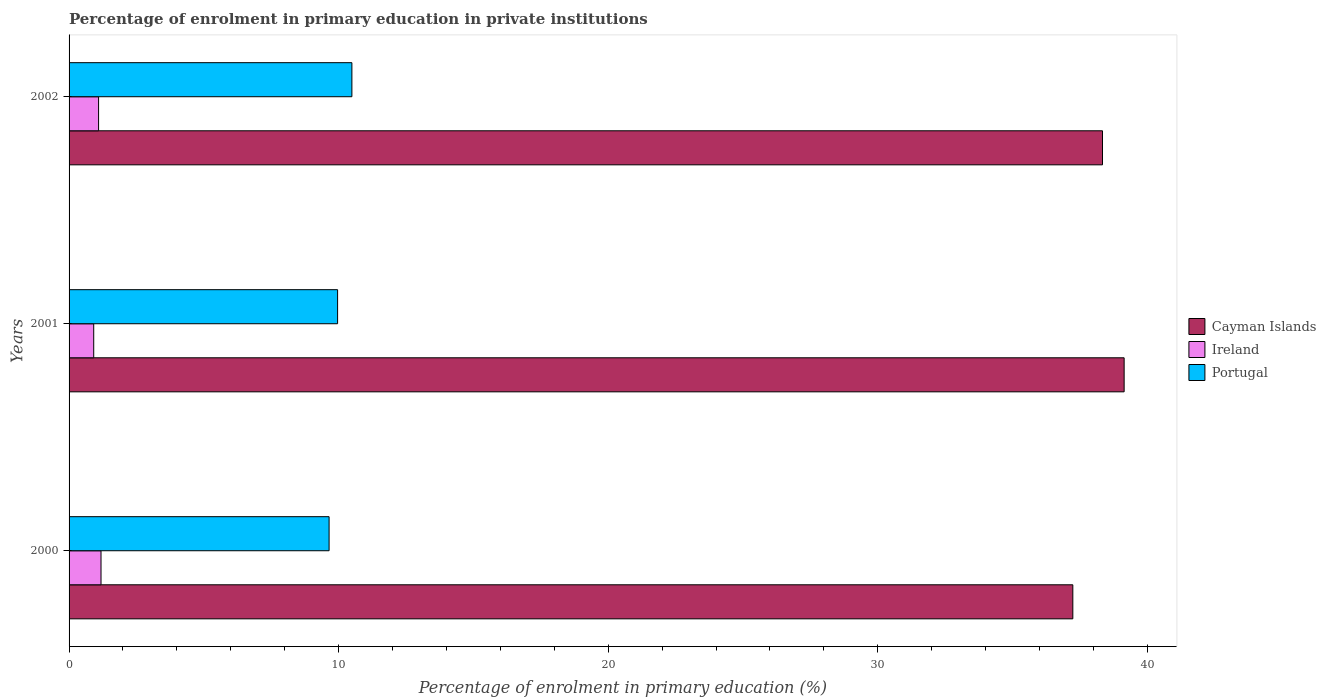How many different coloured bars are there?
Offer a very short reply. 3. Are the number of bars on each tick of the Y-axis equal?
Your response must be concise. Yes. How many bars are there on the 2nd tick from the top?
Offer a very short reply. 3. How many bars are there on the 1st tick from the bottom?
Your answer should be compact. 3. What is the label of the 3rd group of bars from the top?
Make the answer very short. 2000. What is the percentage of enrolment in primary education in Portugal in 2000?
Your answer should be very brief. 9.65. Across all years, what is the maximum percentage of enrolment in primary education in Ireland?
Ensure brevity in your answer.  1.18. Across all years, what is the minimum percentage of enrolment in primary education in Ireland?
Your response must be concise. 0.91. In which year was the percentage of enrolment in primary education in Cayman Islands maximum?
Make the answer very short. 2001. What is the total percentage of enrolment in primary education in Cayman Islands in the graph?
Your response must be concise. 114.71. What is the difference between the percentage of enrolment in primary education in Portugal in 2000 and that in 2001?
Your answer should be very brief. -0.32. What is the difference between the percentage of enrolment in primary education in Ireland in 2001 and the percentage of enrolment in primary education in Portugal in 2002?
Keep it short and to the point. -9.58. What is the average percentage of enrolment in primary education in Cayman Islands per year?
Give a very brief answer. 38.24. In the year 2000, what is the difference between the percentage of enrolment in primary education in Portugal and percentage of enrolment in primary education in Cayman Islands?
Give a very brief answer. -27.59. What is the ratio of the percentage of enrolment in primary education in Ireland in 2000 to that in 2001?
Provide a succinct answer. 1.3. Is the percentage of enrolment in primary education in Ireland in 2000 less than that in 2002?
Provide a short and direct response. No. Is the difference between the percentage of enrolment in primary education in Portugal in 2000 and 2002 greater than the difference between the percentage of enrolment in primary education in Cayman Islands in 2000 and 2002?
Your answer should be compact. Yes. What is the difference between the highest and the second highest percentage of enrolment in primary education in Ireland?
Provide a short and direct response. 0.09. What is the difference between the highest and the lowest percentage of enrolment in primary education in Cayman Islands?
Keep it short and to the point. 1.9. In how many years, is the percentage of enrolment in primary education in Cayman Islands greater than the average percentage of enrolment in primary education in Cayman Islands taken over all years?
Your answer should be very brief. 2. Is the sum of the percentage of enrolment in primary education in Ireland in 2000 and 2002 greater than the maximum percentage of enrolment in primary education in Cayman Islands across all years?
Ensure brevity in your answer.  No. What does the 2nd bar from the top in 2000 represents?
Ensure brevity in your answer.  Ireland. What does the 2nd bar from the bottom in 2000 represents?
Your answer should be compact. Ireland. Is it the case that in every year, the sum of the percentage of enrolment in primary education in Ireland and percentage of enrolment in primary education in Portugal is greater than the percentage of enrolment in primary education in Cayman Islands?
Ensure brevity in your answer.  No. How many years are there in the graph?
Keep it short and to the point. 3. What is the difference between two consecutive major ticks on the X-axis?
Provide a short and direct response. 10. Are the values on the major ticks of X-axis written in scientific E-notation?
Provide a short and direct response. No. Does the graph contain any zero values?
Your response must be concise. No. Does the graph contain grids?
Your response must be concise. No. What is the title of the graph?
Make the answer very short. Percentage of enrolment in primary education in private institutions. Does "Congo (Republic)" appear as one of the legend labels in the graph?
Provide a short and direct response. No. What is the label or title of the X-axis?
Your response must be concise. Percentage of enrolment in primary education (%). What is the Percentage of enrolment in primary education (%) in Cayman Islands in 2000?
Provide a short and direct response. 37.23. What is the Percentage of enrolment in primary education (%) in Ireland in 2000?
Make the answer very short. 1.18. What is the Percentage of enrolment in primary education (%) in Portugal in 2000?
Your answer should be compact. 9.65. What is the Percentage of enrolment in primary education (%) in Cayman Islands in 2001?
Offer a terse response. 39.14. What is the Percentage of enrolment in primary education (%) of Ireland in 2001?
Offer a terse response. 0.91. What is the Percentage of enrolment in primary education (%) of Portugal in 2001?
Offer a terse response. 9.96. What is the Percentage of enrolment in primary education (%) in Cayman Islands in 2002?
Your response must be concise. 38.33. What is the Percentage of enrolment in primary education (%) in Ireland in 2002?
Your response must be concise. 1.09. What is the Percentage of enrolment in primary education (%) in Portugal in 2002?
Make the answer very short. 10.49. Across all years, what is the maximum Percentage of enrolment in primary education (%) of Cayman Islands?
Ensure brevity in your answer.  39.14. Across all years, what is the maximum Percentage of enrolment in primary education (%) of Ireland?
Your answer should be compact. 1.18. Across all years, what is the maximum Percentage of enrolment in primary education (%) of Portugal?
Your answer should be very brief. 10.49. Across all years, what is the minimum Percentage of enrolment in primary education (%) in Cayman Islands?
Provide a succinct answer. 37.23. Across all years, what is the minimum Percentage of enrolment in primary education (%) in Ireland?
Provide a short and direct response. 0.91. Across all years, what is the minimum Percentage of enrolment in primary education (%) of Portugal?
Offer a terse response. 9.65. What is the total Percentage of enrolment in primary education (%) in Cayman Islands in the graph?
Offer a terse response. 114.71. What is the total Percentage of enrolment in primary education (%) of Ireland in the graph?
Make the answer very short. 3.19. What is the total Percentage of enrolment in primary education (%) in Portugal in the graph?
Ensure brevity in your answer.  30.1. What is the difference between the Percentage of enrolment in primary education (%) of Cayman Islands in 2000 and that in 2001?
Your answer should be compact. -1.9. What is the difference between the Percentage of enrolment in primary education (%) of Ireland in 2000 and that in 2001?
Keep it short and to the point. 0.27. What is the difference between the Percentage of enrolment in primary education (%) in Portugal in 2000 and that in 2001?
Ensure brevity in your answer.  -0.32. What is the difference between the Percentage of enrolment in primary education (%) of Cayman Islands in 2000 and that in 2002?
Provide a short and direct response. -1.1. What is the difference between the Percentage of enrolment in primary education (%) in Ireland in 2000 and that in 2002?
Ensure brevity in your answer.  0.09. What is the difference between the Percentage of enrolment in primary education (%) of Portugal in 2000 and that in 2002?
Your answer should be compact. -0.85. What is the difference between the Percentage of enrolment in primary education (%) in Cayman Islands in 2001 and that in 2002?
Provide a short and direct response. 0.8. What is the difference between the Percentage of enrolment in primary education (%) of Ireland in 2001 and that in 2002?
Provide a succinct answer. -0.18. What is the difference between the Percentage of enrolment in primary education (%) in Portugal in 2001 and that in 2002?
Keep it short and to the point. -0.53. What is the difference between the Percentage of enrolment in primary education (%) in Cayman Islands in 2000 and the Percentage of enrolment in primary education (%) in Ireland in 2001?
Give a very brief answer. 36.32. What is the difference between the Percentage of enrolment in primary education (%) in Cayman Islands in 2000 and the Percentage of enrolment in primary education (%) in Portugal in 2001?
Make the answer very short. 27.27. What is the difference between the Percentage of enrolment in primary education (%) in Ireland in 2000 and the Percentage of enrolment in primary education (%) in Portugal in 2001?
Provide a succinct answer. -8.78. What is the difference between the Percentage of enrolment in primary education (%) in Cayman Islands in 2000 and the Percentage of enrolment in primary education (%) in Ireland in 2002?
Provide a succinct answer. 36.14. What is the difference between the Percentage of enrolment in primary education (%) of Cayman Islands in 2000 and the Percentage of enrolment in primary education (%) of Portugal in 2002?
Provide a short and direct response. 26.74. What is the difference between the Percentage of enrolment in primary education (%) in Ireland in 2000 and the Percentage of enrolment in primary education (%) in Portugal in 2002?
Provide a succinct answer. -9.31. What is the difference between the Percentage of enrolment in primary education (%) in Cayman Islands in 2001 and the Percentage of enrolment in primary education (%) in Ireland in 2002?
Make the answer very short. 38.04. What is the difference between the Percentage of enrolment in primary education (%) of Cayman Islands in 2001 and the Percentage of enrolment in primary education (%) of Portugal in 2002?
Make the answer very short. 28.65. What is the difference between the Percentage of enrolment in primary education (%) in Ireland in 2001 and the Percentage of enrolment in primary education (%) in Portugal in 2002?
Offer a very short reply. -9.58. What is the average Percentage of enrolment in primary education (%) in Cayman Islands per year?
Ensure brevity in your answer.  38.24. What is the average Percentage of enrolment in primary education (%) in Ireland per year?
Your answer should be very brief. 1.06. What is the average Percentage of enrolment in primary education (%) of Portugal per year?
Offer a terse response. 10.03. In the year 2000, what is the difference between the Percentage of enrolment in primary education (%) of Cayman Islands and Percentage of enrolment in primary education (%) of Ireland?
Your answer should be very brief. 36.05. In the year 2000, what is the difference between the Percentage of enrolment in primary education (%) in Cayman Islands and Percentage of enrolment in primary education (%) in Portugal?
Make the answer very short. 27.59. In the year 2000, what is the difference between the Percentage of enrolment in primary education (%) in Ireland and Percentage of enrolment in primary education (%) in Portugal?
Provide a succinct answer. -8.46. In the year 2001, what is the difference between the Percentage of enrolment in primary education (%) in Cayman Islands and Percentage of enrolment in primary education (%) in Ireland?
Give a very brief answer. 38.22. In the year 2001, what is the difference between the Percentage of enrolment in primary education (%) of Cayman Islands and Percentage of enrolment in primary education (%) of Portugal?
Provide a short and direct response. 29.18. In the year 2001, what is the difference between the Percentage of enrolment in primary education (%) of Ireland and Percentage of enrolment in primary education (%) of Portugal?
Make the answer very short. -9.05. In the year 2002, what is the difference between the Percentage of enrolment in primary education (%) in Cayman Islands and Percentage of enrolment in primary education (%) in Ireland?
Give a very brief answer. 37.24. In the year 2002, what is the difference between the Percentage of enrolment in primary education (%) in Cayman Islands and Percentage of enrolment in primary education (%) in Portugal?
Make the answer very short. 27.84. In the year 2002, what is the difference between the Percentage of enrolment in primary education (%) of Ireland and Percentage of enrolment in primary education (%) of Portugal?
Your response must be concise. -9.4. What is the ratio of the Percentage of enrolment in primary education (%) of Cayman Islands in 2000 to that in 2001?
Give a very brief answer. 0.95. What is the ratio of the Percentage of enrolment in primary education (%) of Ireland in 2000 to that in 2001?
Keep it short and to the point. 1.3. What is the ratio of the Percentage of enrolment in primary education (%) in Portugal in 2000 to that in 2001?
Offer a very short reply. 0.97. What is the ratio of the Percentage of enrolment in primary education (%) in Cayman Islands in 2000 to that in 2002?
Give a very brief answer. 0.97. What is the ratio of the Percentage of enrolment in primary education (%) in Ireland in 2000 to that in 2002?
Make the answer very short. 1.08. What is the ratio of the Percentage of enrolment in primary education (%) of Portugal in 2000 to that in 2002?
Your answer should be compact. 0.92. What is the ratio of the Percentage of enrolment in primary education (%) in Cayman Islands in 2001 to that in 2002?
Ensure brevity in your answer.  1.02. What is the ratio of the Percentage of enrolment in primary education (%) in Ireland in 2001 to that in 2002?
Offer a terse response. 0.84. What is the ratio of the Percentage of enrolment in primary education (%) of Portugal in 2001 to that in 2002?
Keep it short and to the point. 0.95. What is the difference between the highest and the second highest Percentage of enrolment in primary education (%) in Cayman Islands?
Your answer should be compact. 0.8. What is the difference between the highest and the second highest Percentage of enrolment in primary education (%) of Ireland?
Keep it short and to the point. 0.09. What is the difference between the highest and the second highest Percentage of enrolment in primary education (%) in Portugal?
Make the answer very short. 0.53. What is the difference between the highest and the lowest Percentage of enrolment in primary education (%) in Cayman Islands?
Offer a terse response. 1.9. What is the difference between the highest and the lowest Percentage of enrolment in primary education (%) of Ireland?
Ensure brevity in your answer.  0.27. What is the difference between the highest and the lowest Percentage of enrolment in primary education (%) in Portugal?
Provide a short and direct response. 0.85. 